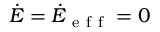<formula> <loc_0><loc_0><loc_500><loc_500>\dot { E } = \dot { E } _ { e f f } = 0</formula> 